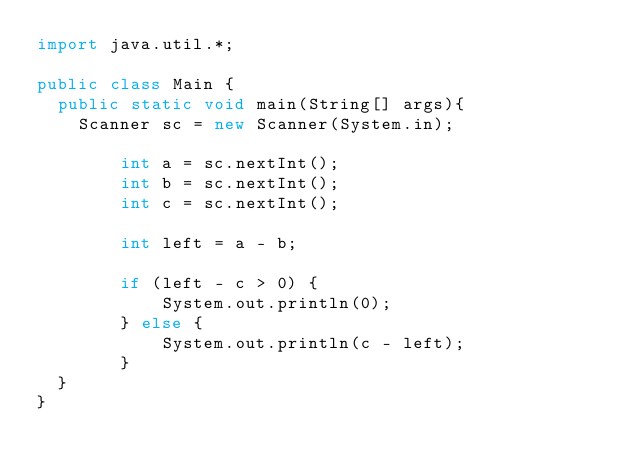Convert code to text. <code><loc_0><loc_0><loc_500><loc_500><_Java_>import java.util.*;
 
public class Main {
	public static void main(String[] args){
		Scanner sc = new Scanner(System.in);
        
        int a = sc.nextInt();
        int b = sc.nextInt();
        int c = sc.nextInt();

        int left = a - b;

        if (left - c > 0) {
            System.out.println(0);
        } else {
            System.out.println(c - left);
        }
	}
}
</code> 